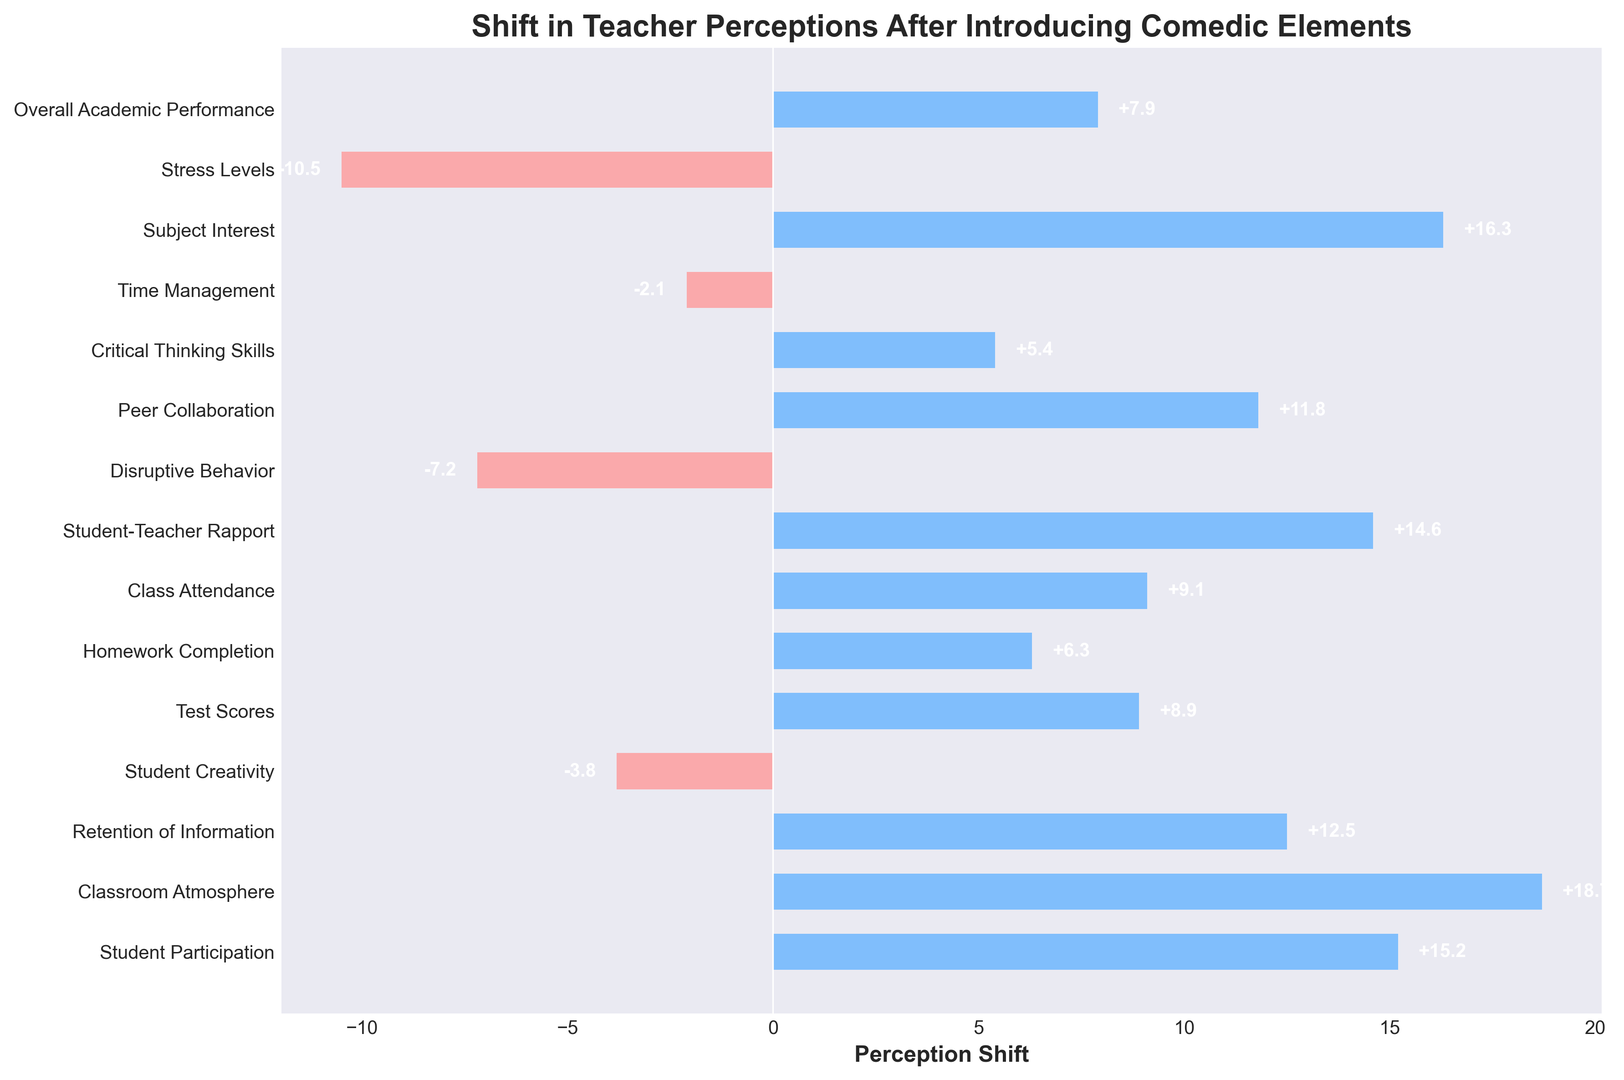Which perception had the highest positive shift after introducing comedic elements? The highest positive bar in the chart represents Classroom Atmosphere, indicating it had the highest shift in teacher perceptions.
Answer: Classroom Atmosphere Which perception had the most significant negative shift? The lowest bar represents Stress Levels, indicating it had the most significant negative shift.
Answer: Stress Levels What is the combined perception shift for Student Participation and Test Scores? Student Participation shift is 15.2, and Test Scores shift is 8.9. Adding them gives 15.2 + 8.9 = 24.1.
Answer: 24.1 How does the shift in Student Creativity compare to that in Disruptive Behavior? Student Creativity has a shift of -3.8, and Disruptive Behavior has a shift of -7.2. Comparing these, Student Creativity has a higher shift than Disruptive Behavior.
Answer: Student Creativity has a higher shift What is the average shift in perception for Retention of Information, Peer Collaboration, and Homework Completion? Their shifts are 12.5, 11.8, and 6.3 respectively. The sum is 12.5 + 11.8 + 6.3 = 30.6. The average is 30.6 / 3 = 10.2.
Answer: 10.2 Which perceptions have a shift greater than 10 but less than 20? The bars for Student Participation (15.2), Classroom Atmosphere (18.7), Subject Interest (16.3), and Peer Collaboration (11.8) fall within this range.
Answer: Student Participation, Classroom Atmosphere, Subject Interest, Peer Collaboration What is the total shift for all positive perceptions? Adding the positive shifts: 15.2 + 18.7 + 12.5 + 8.9 + 6.3 + 9.1 + 14.6 + 11.8 + 5.4 + 16.3 + 7.9 = 126.7.
Answer: 126.7 How many perceptions had negative shifts? Counting the bars in red: Student Creativity, Disruptive Behavior, Time Management, Stress Levels. There are 4 negative shifts.
Answer: 4 What is the difference in perception shifts between the highest positive and lowest negative values? The highest positive shift is Classroom Atmosphere (18.7), and the lowest negative shift is Stress Levels (-10.5). The difference is 18.7 - (-10.5) = 18.7 + 10.5 = 29.2.
Answer: 29.2 What is the shift in perception for Student-Teacher Rapport in comparison to Subject Interest? Student-Teacher Rapport has a shift of 14.6, and Subject Interest has a shift of 16.3. Subject Interest has a higher shift.
Answer: Subject Interest has a higher shift 